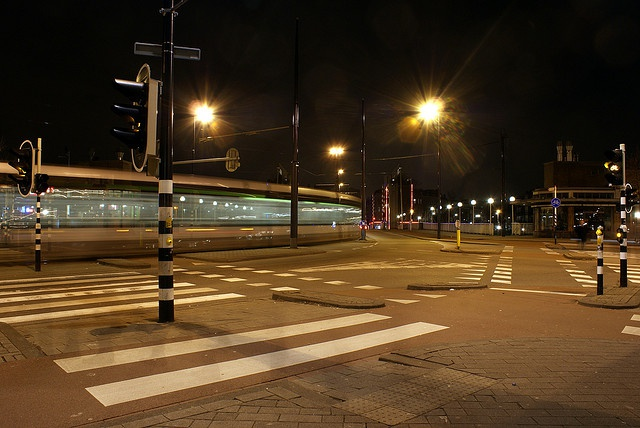Describe the objects in this image and their specific colors. I can see train in black, gray, olive, and maroon tones, traffic light in black, gray, olive, and maroon tones, traffic light in black, tan, and maroon tones, traffic light in black, maroon, ivory, and olive tones, and traffic light in black, maroon, and olive tones in this image. 